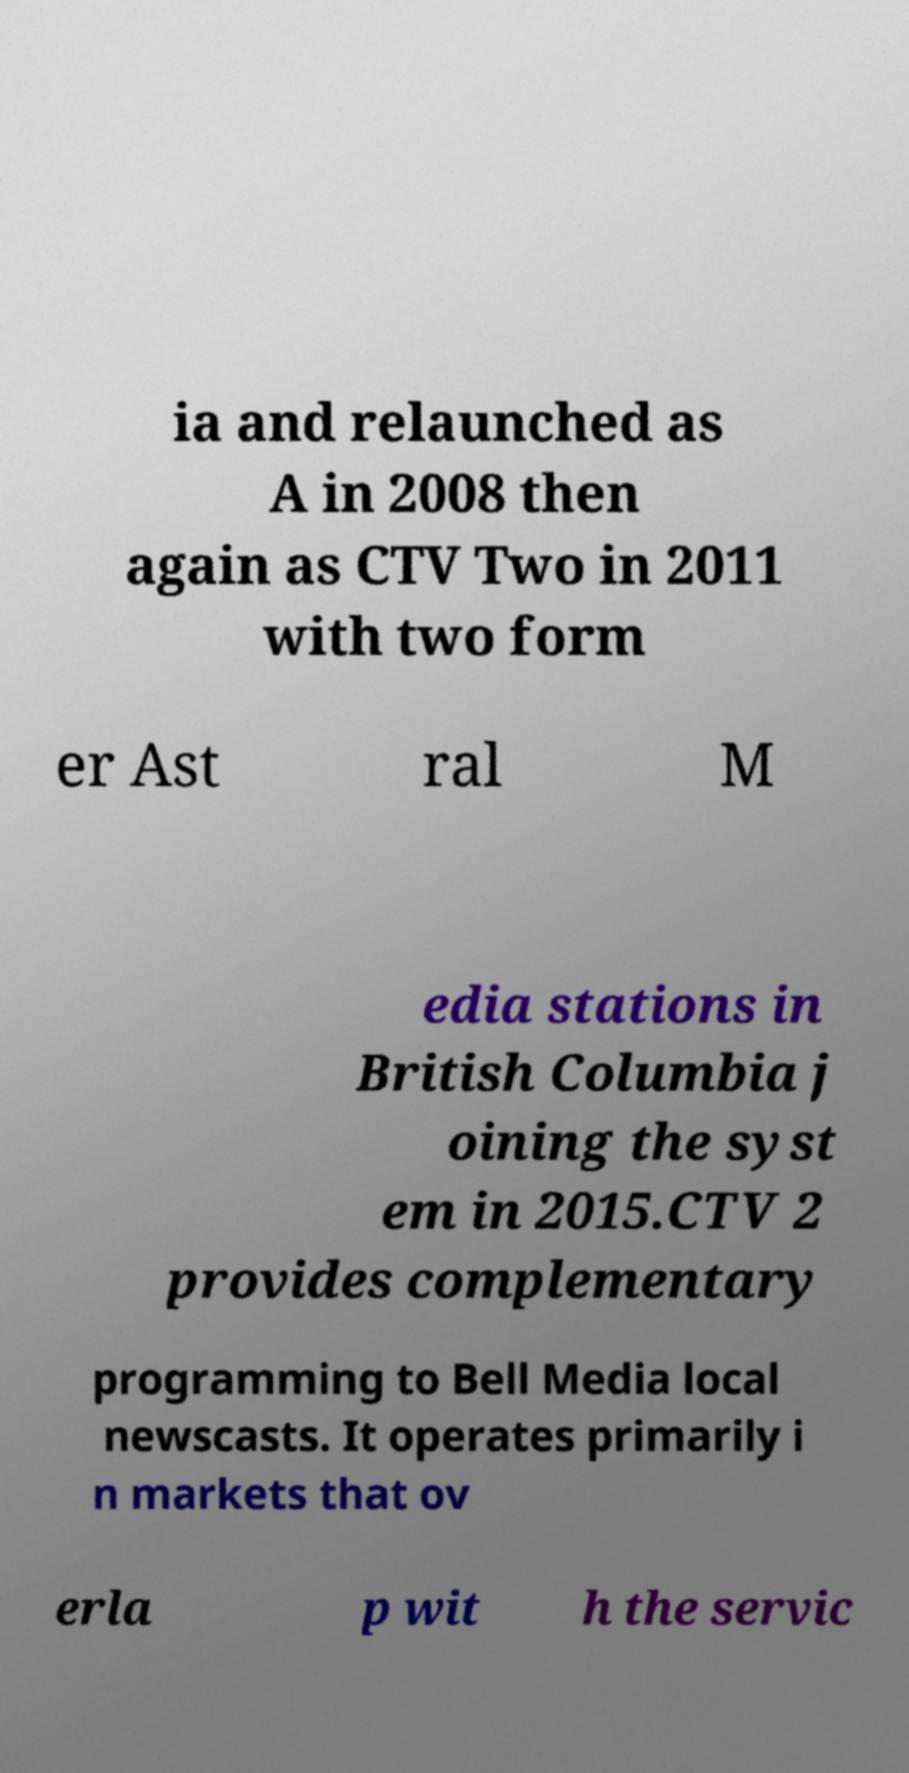What messages or text are displayed in this image? I need them in a readable, typed format. ia and relaunched as A in 2008 then again as CTV Two in 2011 with two form er Ast ral M edia stations in British Columbia j oining the syst em in 2015.CTV 2 provides complementary programming to Bell Media local newscasts. It operates primarily i n markets that ov erla p wit h the servic 